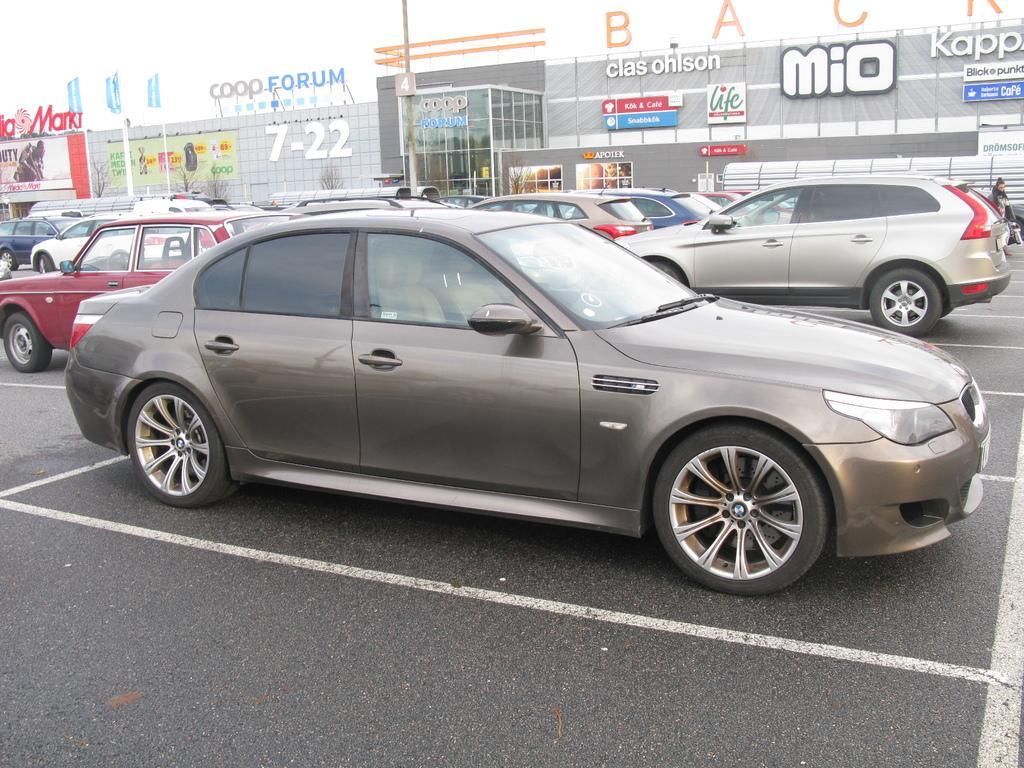In one or two sentences, can you explain what this image depicts? In this image we can see a group of vehicles and a person on the road. On the backside we can see some buildings, boards with some text on them, the flags and some poles. 